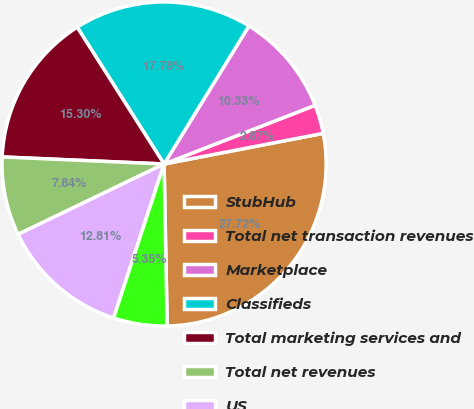Convert chart. <chart><loc_0><loc_0><loc_500><loc_500><pie_chart><fcel>StubHub<fcel>Total net transaction revenues<fcel>Marketplace<fcel>Classifieds<fcel>Total marketing services and<fcel>Total net revenues<fcel>US<fcel>International<nl><fcel>27.72%<fcel>2.87%<fcel>10.33%<fcel>17.78%<fcel>15.3%<fcel>7.84%<fcel>12.81%<fcel>5.35%<nl></chart> 